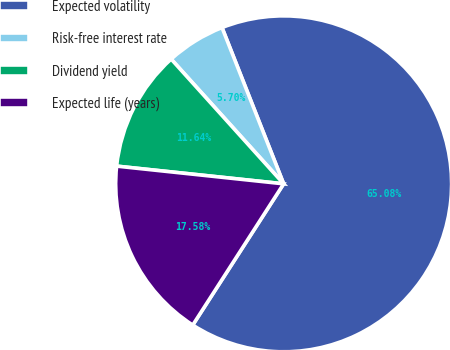<chart> <loc_0><loc_0><loc_500><loc_500><pie_chart><fcel>Expected volatility<fcel>Risk-free interest rate<fcel>Dividend yield<fcel>Expected life (years)<nl><fcel>65.09%<fcel>5.7%<fcel>11.64%<fcel>17.58%<nl></chart> 